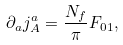<formula> <loc_0><loc_0><loc_500><loc_500>\partial _ { a } j ^ { a } _ { A } = \frac { N _ { f } } { \pi } F _ { 0 1 } ,</formula> 